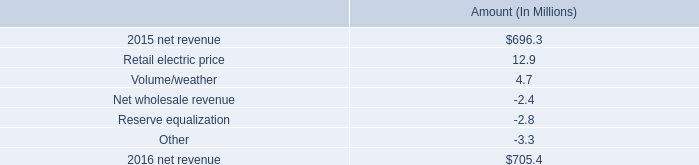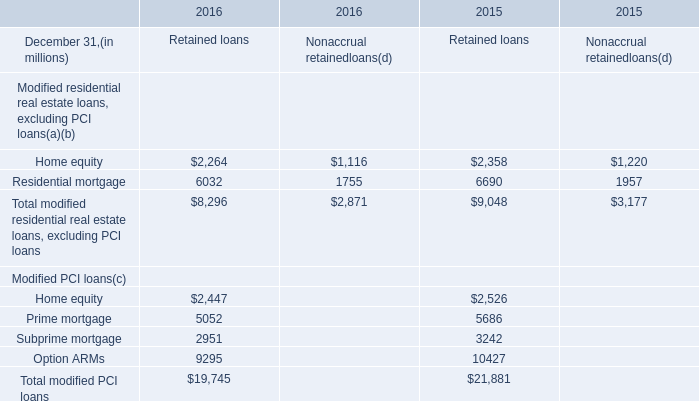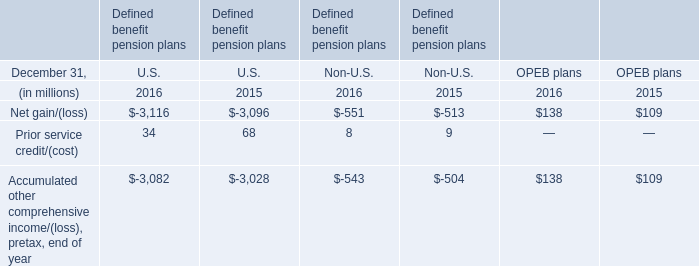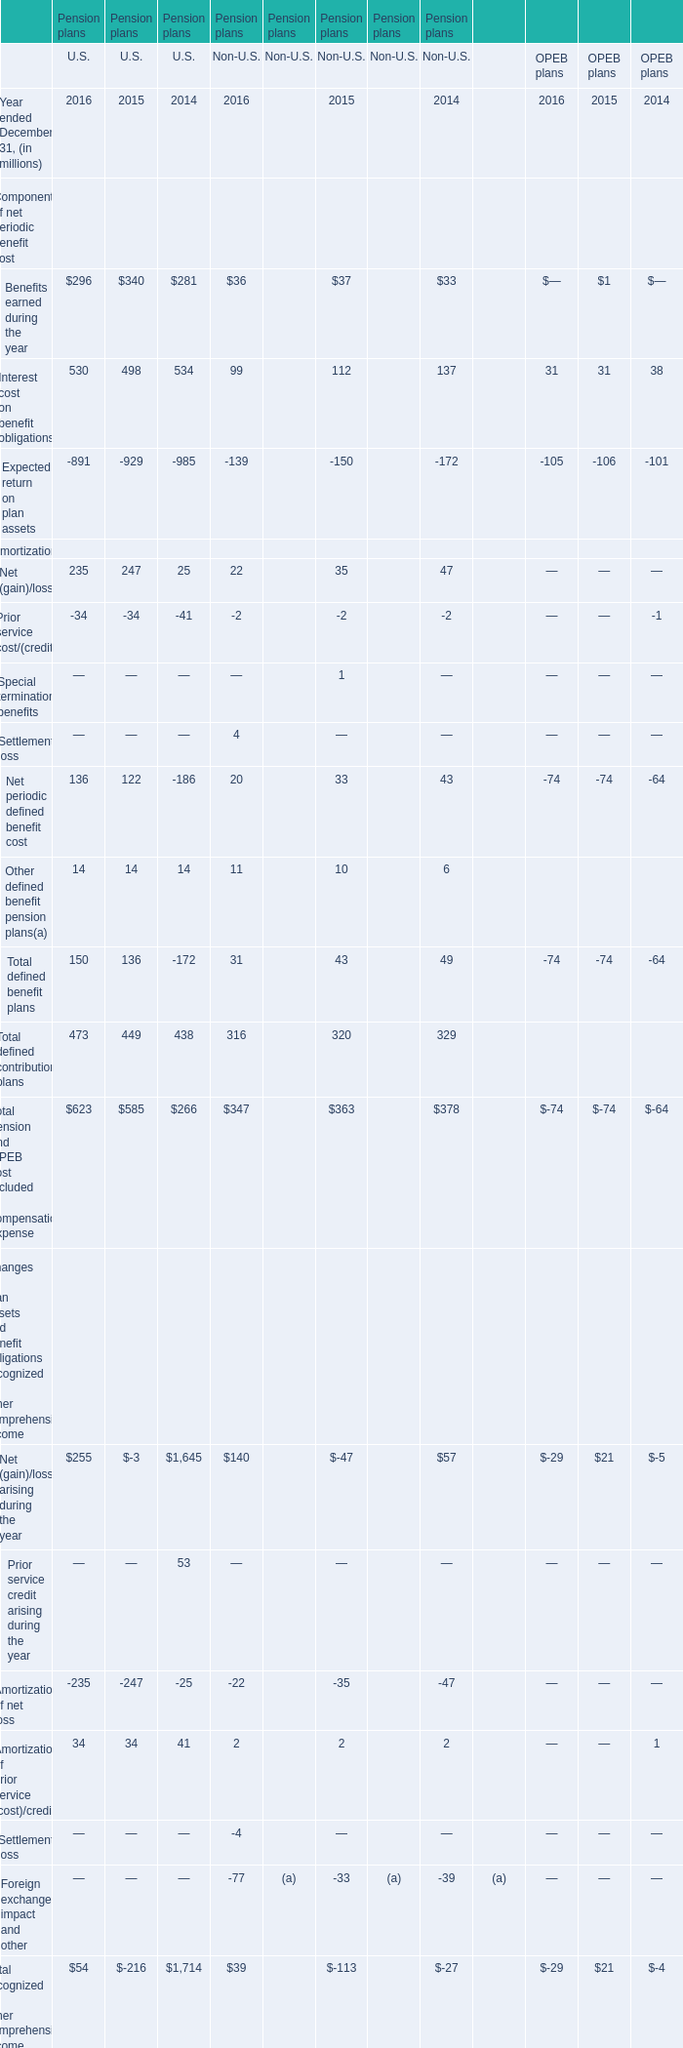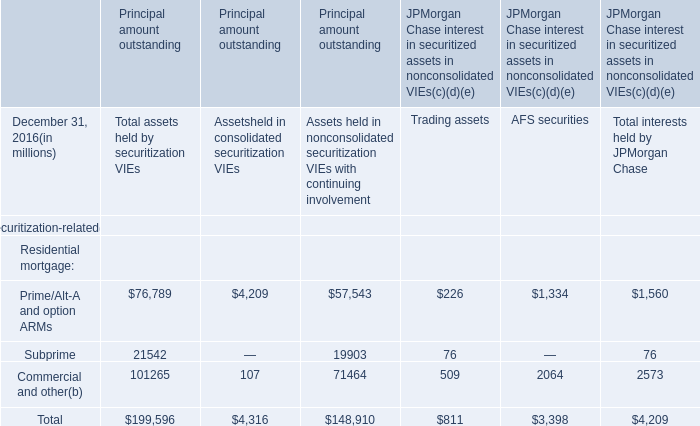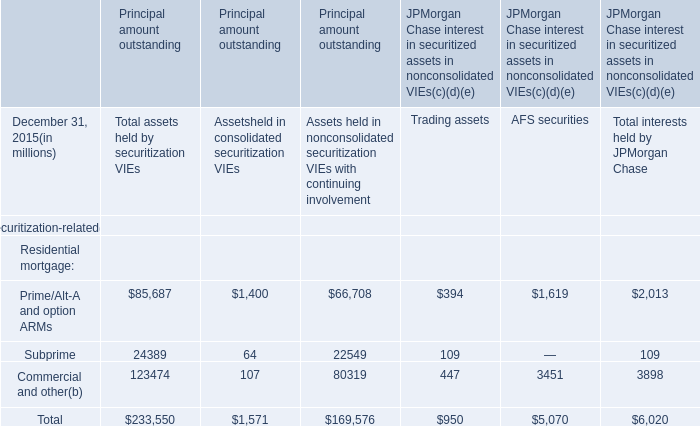What's the sum of all Defined benefit pension plans that are positive in 2016? (in million) 
Computations: (34 + 68)
Answer: 102.0. 